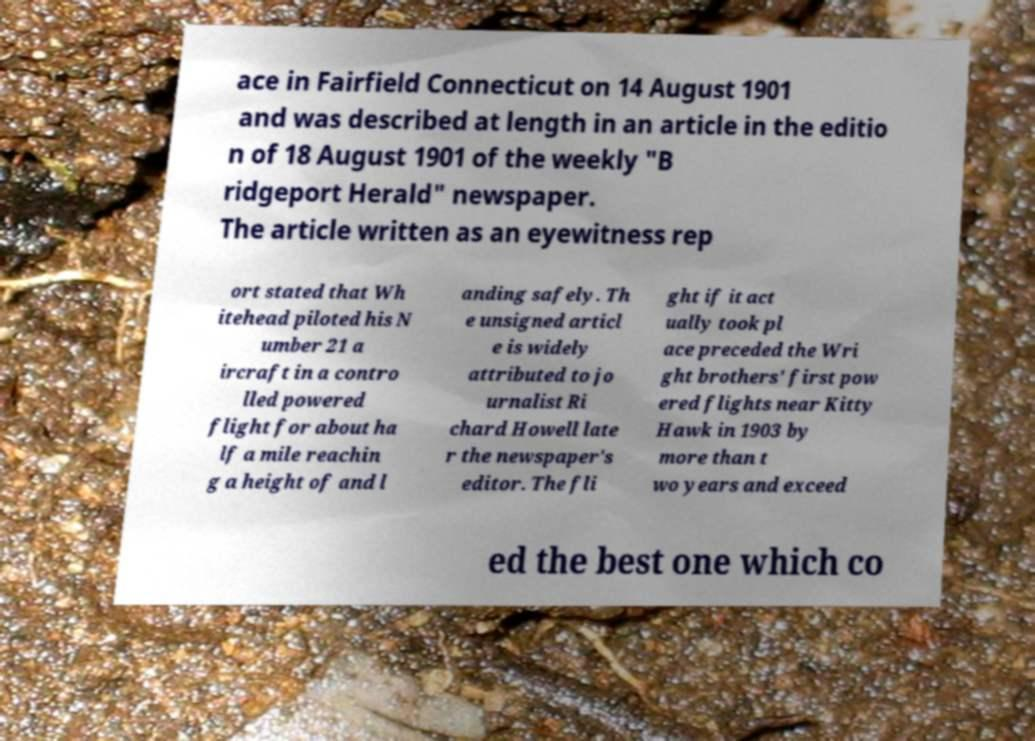For documentation purposes, I need the text within this image transcribed. Could you provide that? ace in Fairfield Connecticut on 14 August 1901 and was described at length in an article in the editio n of 18 August 1901 of the weekly "B ridgeport Herald" newspaper. The article written as an eyewitness rep ort stated that Wh itehead piloted his N umber 21 a ircraft in a contro lled powered flight for about ha lf a mile reachin g a height of and l anding safely. Th e unsigned articl e is widely attributed to jo urnalist Ri chard Howell late r the newspaper's editor. The fli ght if it act ually took pl ace preceded the Wri ght brothers' first pow ered flights near Kitty Hawk in 1903 by more than t wo years and exceed ed the best one which co 